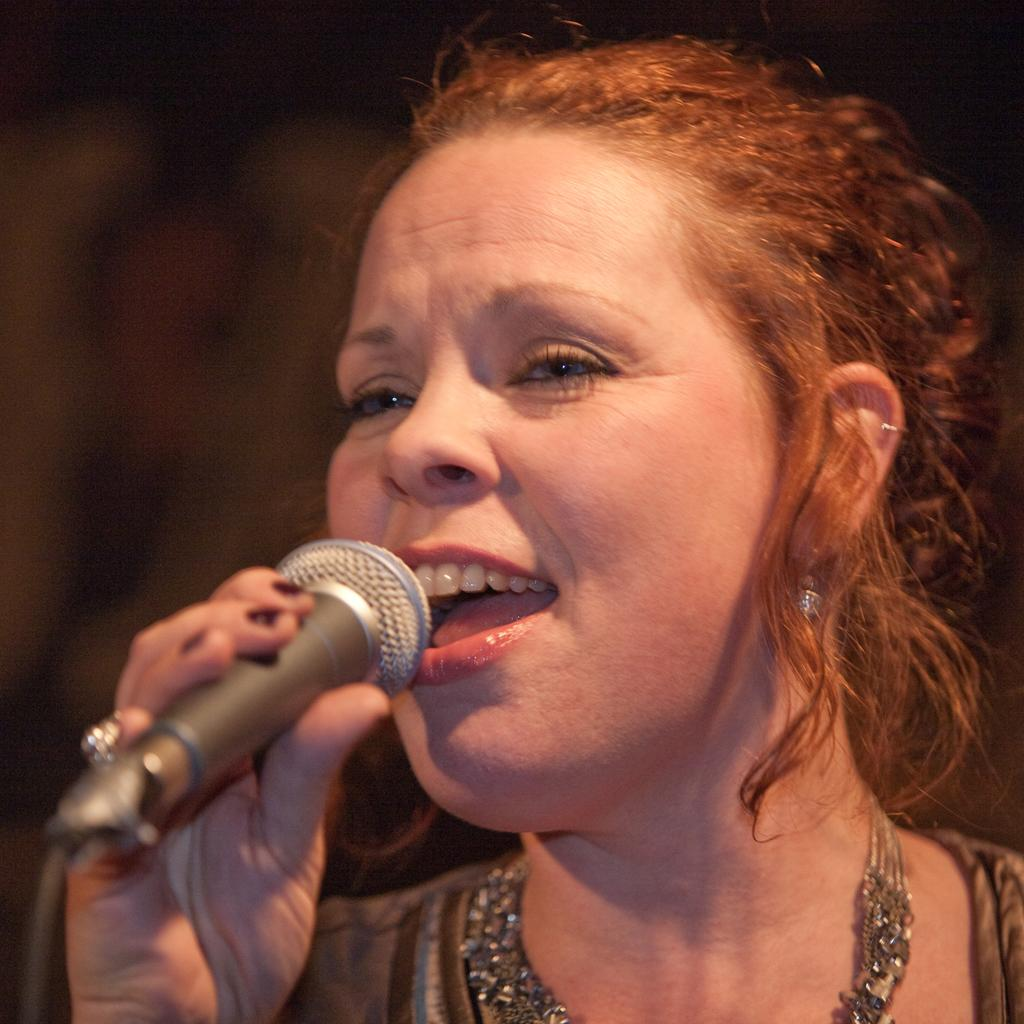What is the main subject of the image? The main subject of the image is a woman. What is the woman doing in the image? The woman is singing on a mic in the image. What accessories is the woman wearing in the image? The woman is wearing earrings and a necklace in the image. What is the color of the background in the image? The background of the image is black. Can you tell me how many trains are visible in the image? There are no trains present in the image; it features a woman singing on a mic. What type of pleasure can be seen being derived from the activity in the image? The image does not depict any specific pleasure or emotion; it simply shows a woman singing on a mic. 